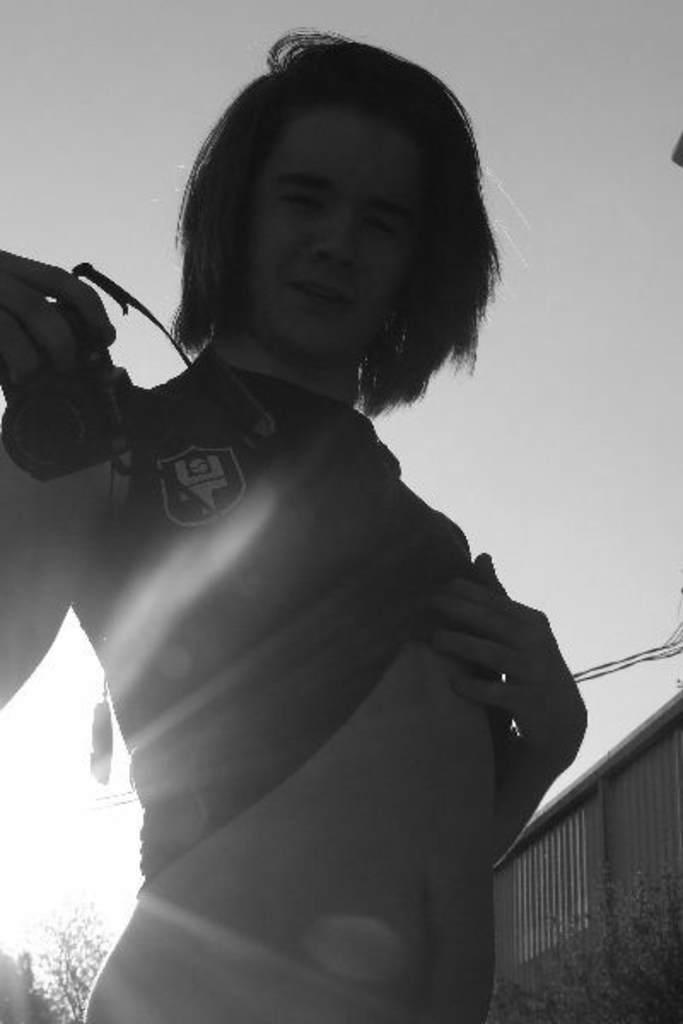What is the color scheme of the image? The image is black and white. What is the person in the image doing? The person is holding a camera in the image. What type of natural environment can be seen in the image? There are trees in the image. What structures are visible in the background of the image? There is a house in the background of the image. What is visible in the sky in the image? The sky is visible in the background of the image. Is the person in the image driving a car while holding the camera? No, the person is not driving a car in the image; they are holding a camera while standing or walking. Can you see a glove on the person's hand in the image? No, there is no glove visible on the person's hand in the image. 